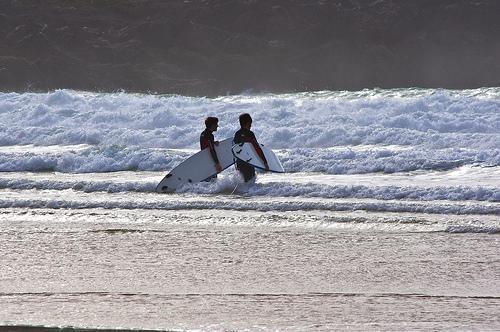How many people are there?
Give a very brief answer. 2. 